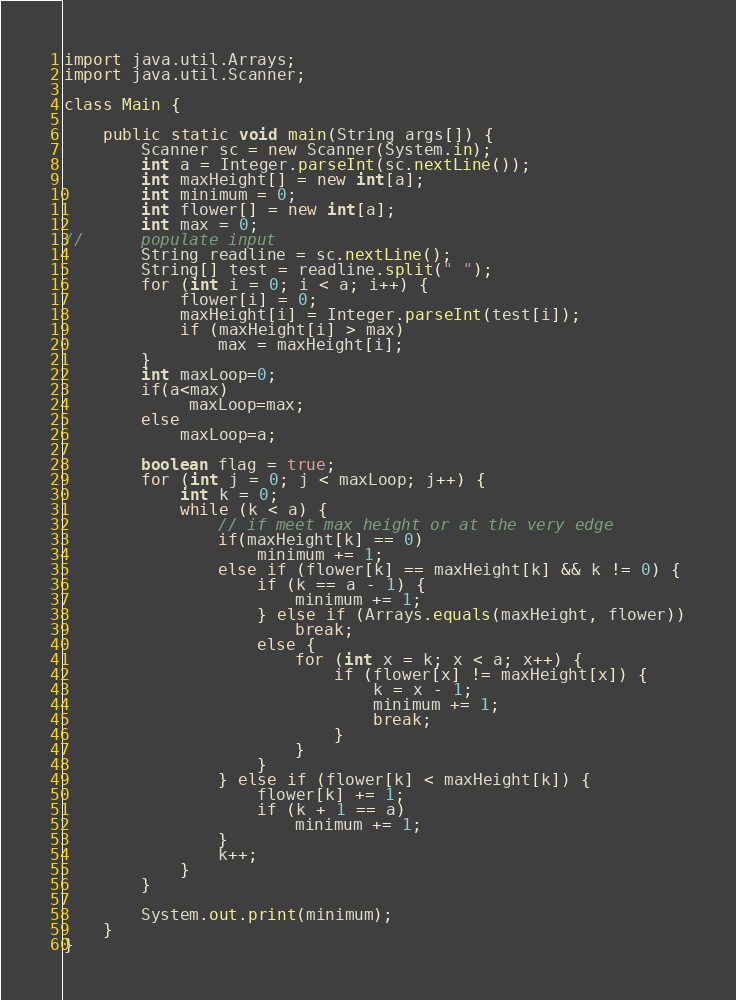<code> <loc_0><loc_0><loc_500><loc_500><_Java_>import java.util.Arrays;
import java.util.Scanner;

class Main {

	public static void main(String args[]) {
		Scanner sc = new Scanner(System.in);
		int a = Integer.parseInt(sc.nextLine());
		int maxHeight[] = new int[a];
		int minimum = 0;
		int flower[] = new int[a];
		int max = 0;
//		populate input
		String readline = sc.nextLine();
		String[] test = readline.split(" ");
		for (int i = 0; i < a; i++) {
			flower[i] = 0;
			maxHeight[i] = Integer.parseInt(test[i]);
			if (maxHeight[i] > max)
				max = maxHeight[i];
		}
		int maxLoop=0;
		if(a<max)
			 maxLoop=max;
		else
			maxLoop=a;

		boolean flag = true;
		for (int j = 0; j < maxLoop; j++) {
			int k = 0;
			while (k < a) {
				// if meet max height or at the very edge
				if(maxHeight[k] == 0)
					minimum += 1;
				else if (flower[k] == maxHeight[k] && k != 0) {
					if (k == a - 1) {
						minimum += 1;
					} else if (Arrays.equals(maxHeight, flower))
						break;
					else {
						for (int x = k; x < a; x++) {
							if (flower[x] != maxHeight[x]) {
								k = x - 1;
								minimum += 1;
								break;
							}
						}
					}
				} else if (flower[k] < maxHeight[k]) {
					flower[k] += 1;
					if (k + 1 == a)
						minimum += 1;
				}
				k++;
			}
		}

		System.out.print(minimum);
	}
}</code> 